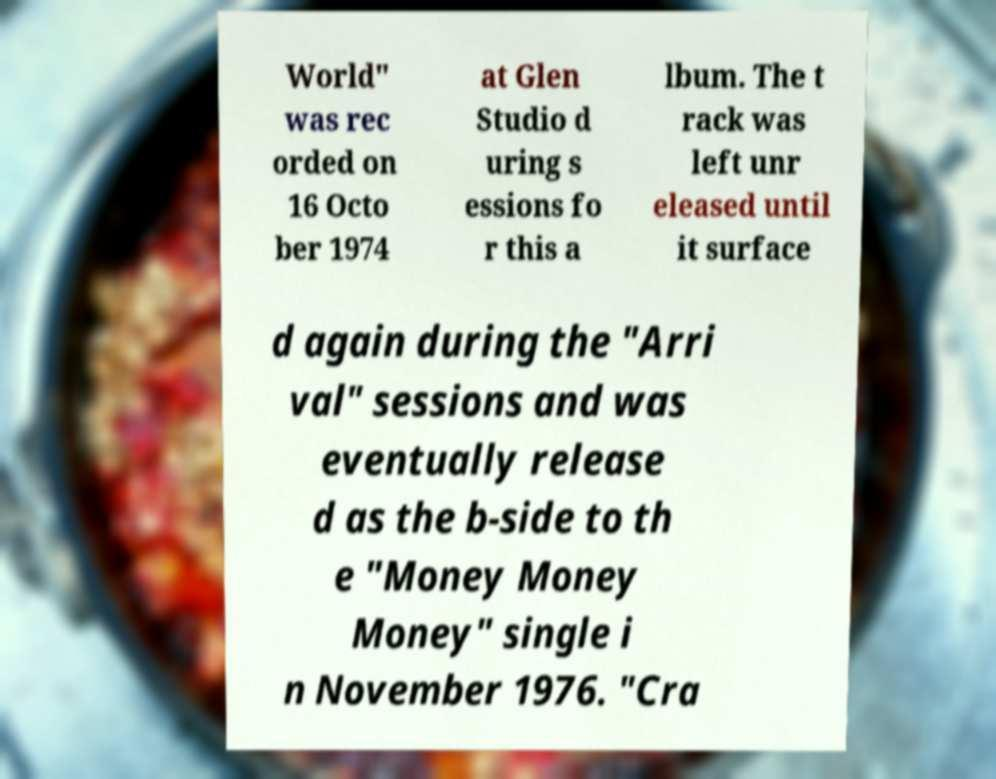Could you extract and type out the text from this image? World" was rec orded on 16 Octo ber 1974 at Glen Studio d uring s essions fo r this a lbum. The t rack was left unr eleased until it surface d again during the "Arri val" sessions and was eventually release d as the b-side to th e "Money Money Money" single i n November 1976. "Cra 